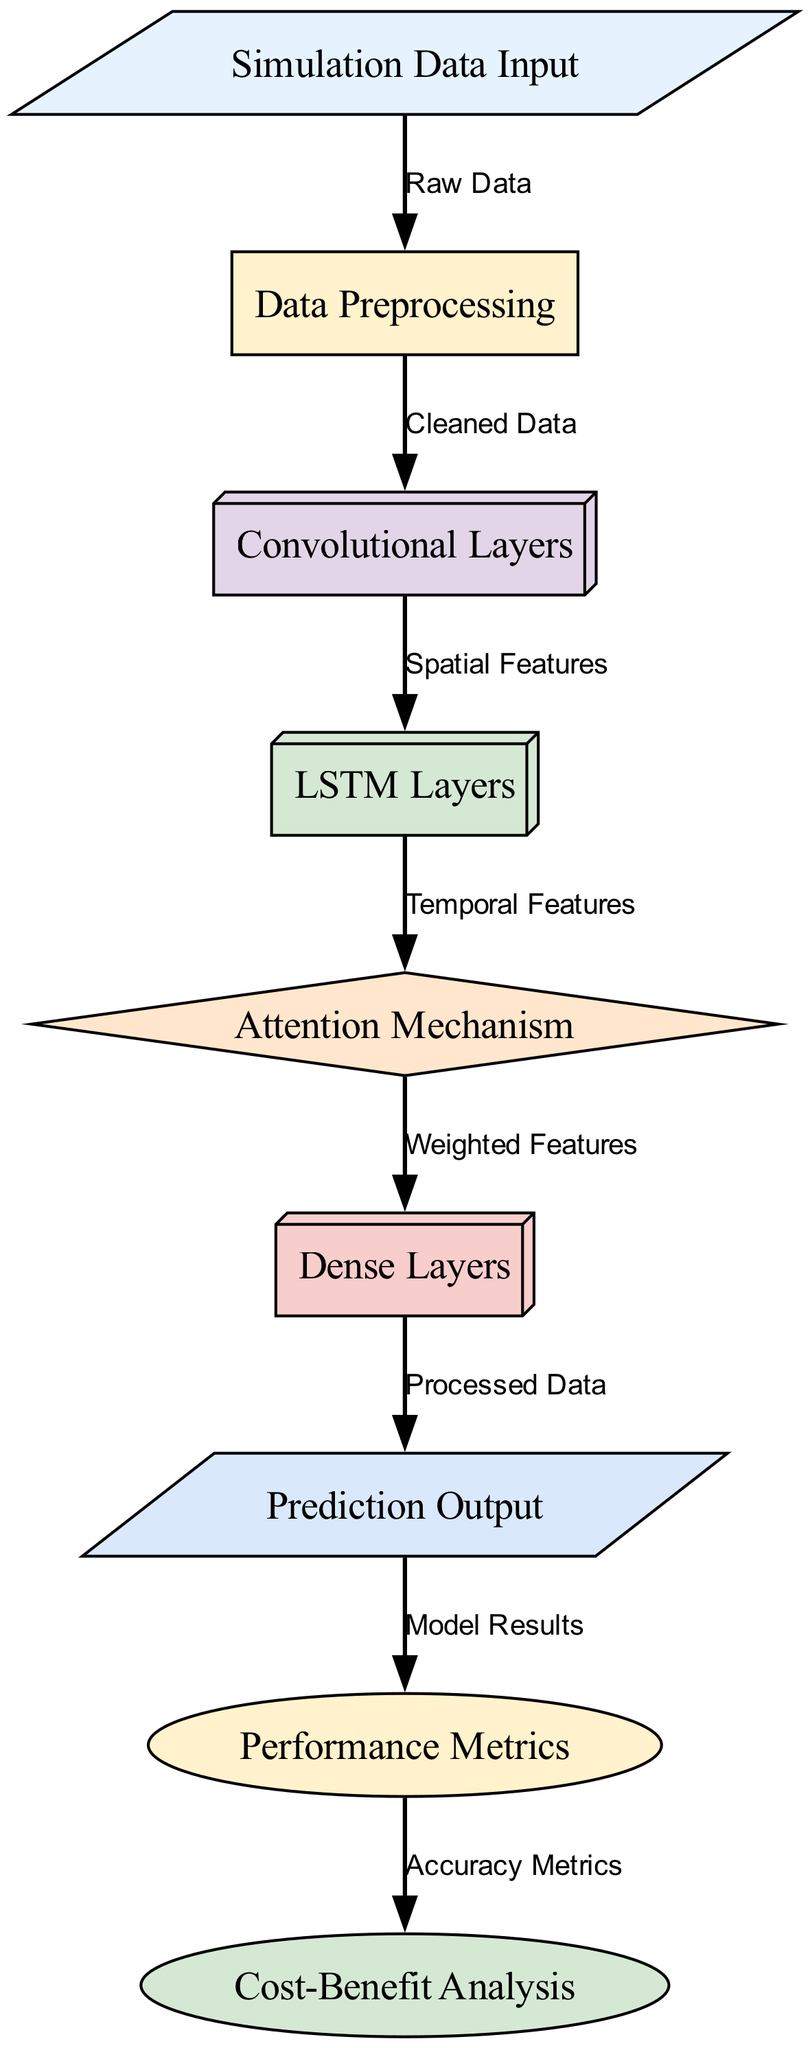What is the input to the neural network? The input node labeled "Simulation Data Input" shows that simulation data is fed into the neural network for processing.
Answer: Simulation Data Input How many layers are in the architecture? The diagram shows five distinct processing layers (Data Preprocessing, Convolutional Layers, LSTM Layers, Attention Mechanism, and Dense Layers) connected from input to output.
Answer: Five What type of data follows the Convolutional Layers? The edge from Convolutional Layers to LSTM Layers is labeled "Spatial Features," indicating that the processed spatial features are passed to the next layer.
Answer: Spatial Features What is the final output of the model? Following the layers of the architecture, the final node labeled "Prediction Output" shows what the model yields after processing input data.
Answer: Prediction Output Which mechanism receives input from the LSTM Layers? The diagram indicates that the Attention Mechanism receives input directly from the LSTM Layers, as shown by the edge connecting these two nodes.
Answer: Attention Mechanism How does the output relate to performance metrics? The edge connecting the "Prediction Output" node to the "Performance Metrics" node is labeled "Model Results," suggesting that results from the prediction are evaluated through performance metrics.
Answer: Model Results What features are weighted in the Attention Mechanism? The connections from the Attention Mechanism to the Dense Layers indicate that the output is labeled "Weighted Features," which refers to the features being adjusted for importance in the prediction task.
Answer: Weighted Features What is the role of the Dense Layers? The flow leading to the node from the Attention Mechanism states that features are processed and passed along as "Processed Data," indicating the function of the Dense Layers to finalize data for prediction.
Answer: Processed Data What metrics influence the cost-benefit analysis? The pathway leading from the Performance Metrics to the Cost-Benefit Analysis node shows that the information processed as "Accuracy Metrics" is critical for making cost-benefit decisions.
Answer: Accuracy Metrics 